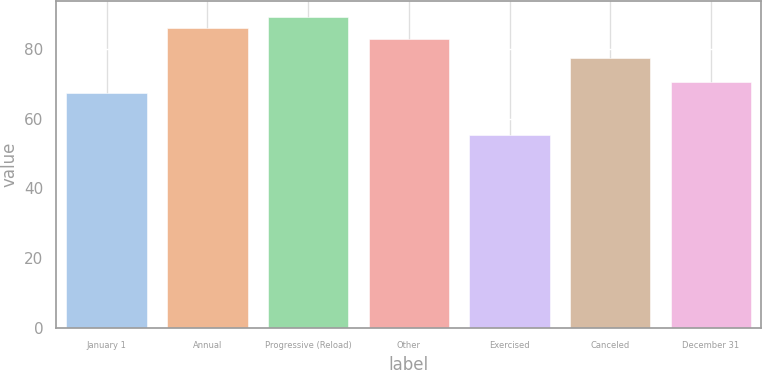Convert chart. <chart><loc_0><loc_0><loc_500><loc_500><bar_chart><fcel>January 1<fcel>Annual<fcel>Progressive (Reload)<fcel>Other<fcel>Exercised<fcel>Canceled<fcel>December 31<nl><fcel>67.41<fcel>86.11<fcel>89.29<fcel>82.93<fcel>55.34<fcel>77.36<fcel>70.59<nl></chart> 